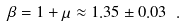Convert formula to latex. <formula><loc_0><loc_0><loc_500><loc_500>\beta = 1 + \mu \approx 1 . 3 5 \pm 0 . 0 3 \ .</formula> 